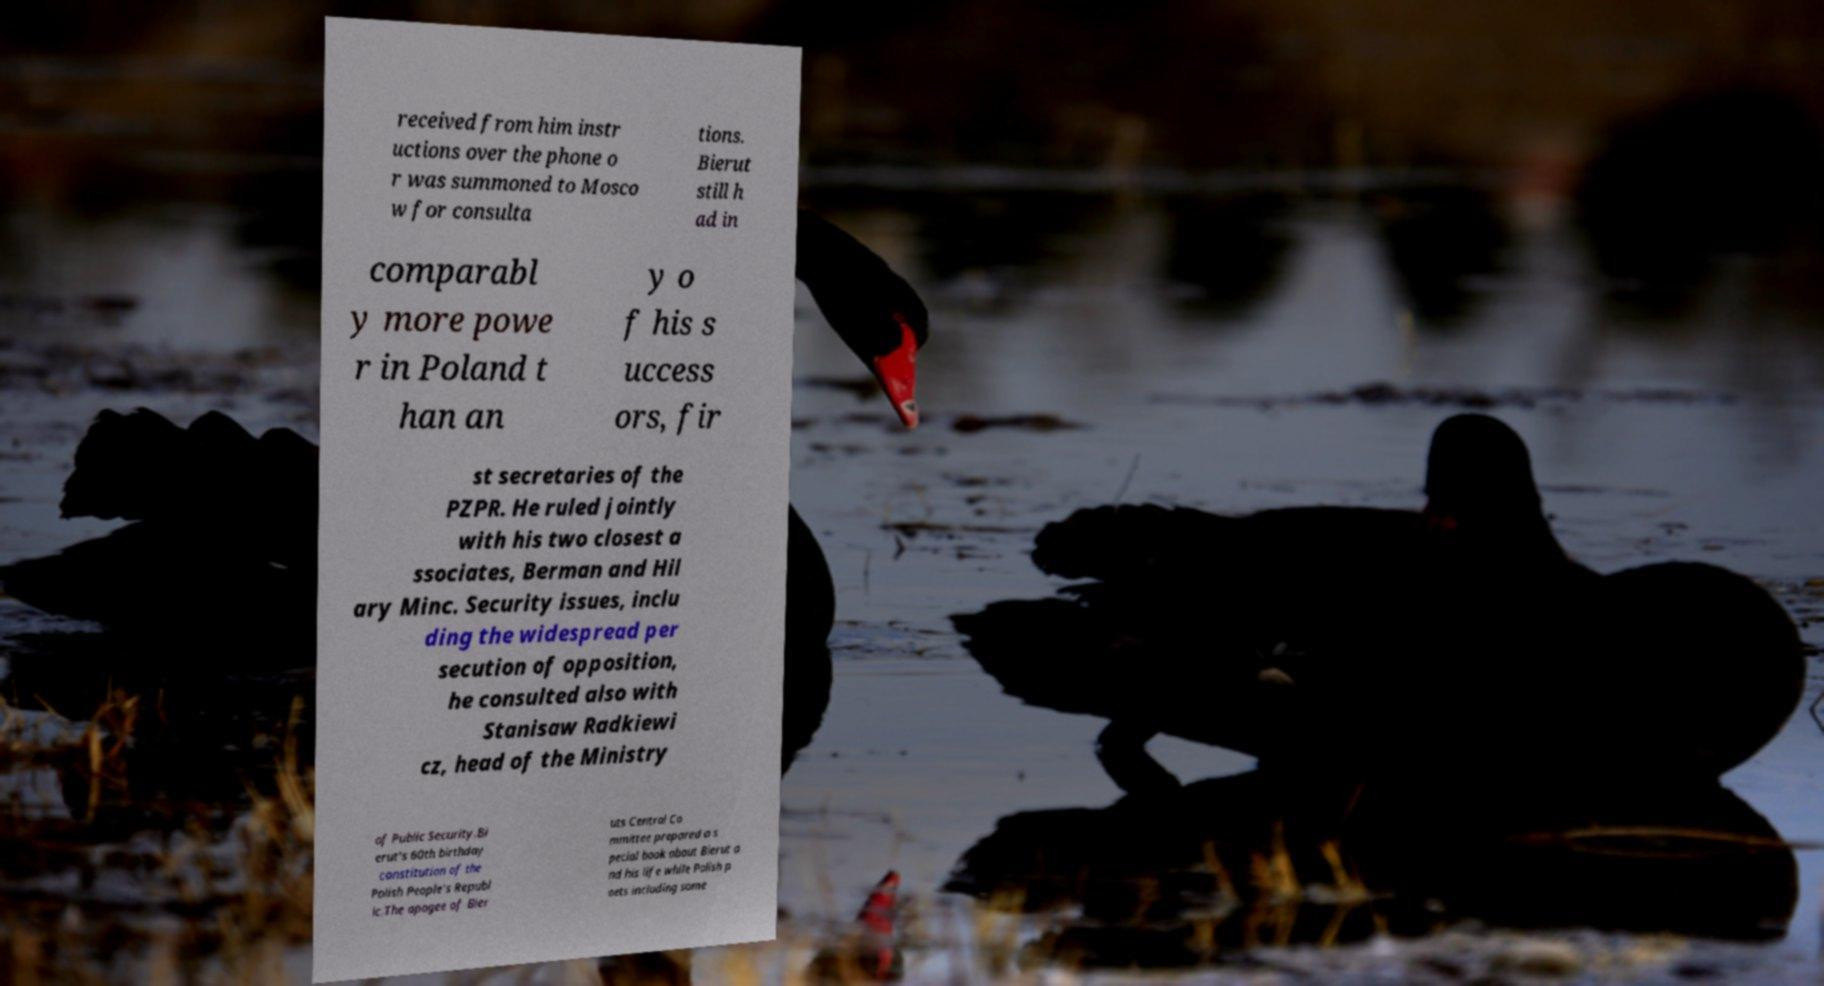Can you read and provide the text displayed in the image?This photo seems to have some interesting text. Can you extract and type it out for me? received from him instr uctions over the phone o r was summoned to Mosco w for consulta tions. Bierut still h ad in comparabl y more powe r in Poland t han an y o f his s uccess ors, fir st secretaries of the PZPR. He ruled jointly with his two closest a ssociates, Berman and Hil ary Minc. Security issues, inclu ding the widespread per secution of opposition, he consulted also with Stanisaw Radkiewi cz, head of the Ministry of Public Security.Bi erut's 60th birthday constitution of the Polish People's Republ ic.The apogee of Bier uts Central Co mmittee prepared a s pecial book about Bierut a nd his life while Polish p oets including some 